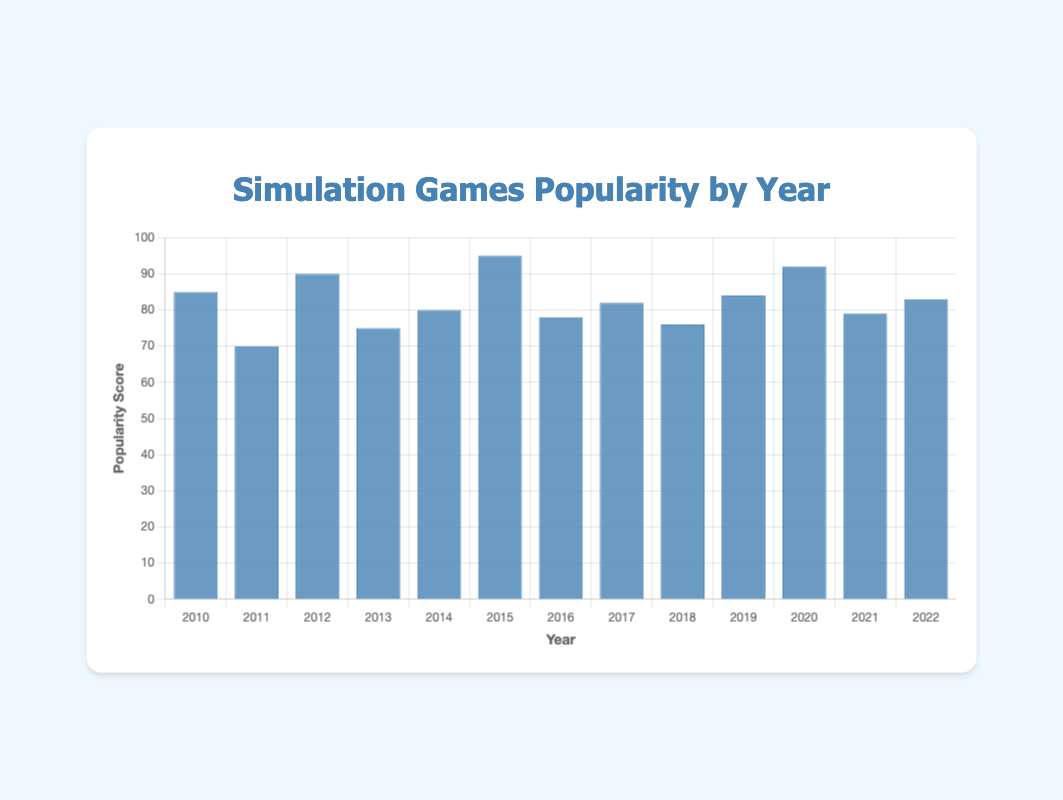Which year had the highest popularity score? Find the tallest blue bar in the chart. The bar for the year 2015 is the tallest, indicating the highest popularity score of 95.
Answer: 2015 Which game corresponded to the highest popularity score? Look at the highest bar representing the year 2015, then check the tooltip or data provided which shows that "Cities: Skylines" corresponded to the highest popularity score of 95.
Answer: Cities: Skylines What was the average popularity score over the years? Sum the popularity scores from 2010 to 2022 [85, 70, 90, 75, 80, 95, 78, 82, 76, 84, 92, 79, 83], resulting in 979. Then divide the sum by the number of years (13), which gives an average of 75.3.
Answer: 75.3 Which year had the lowest popularity score? Identify the shortest blue bar. The bar for the year 2011 is the shortest, indicating the lowest popularity score of 70.
Answer: 2011 What is the difference in popularity scores between the years 2014 and 2020? Subtract the popularity score of 2014 (80) from the popularity score of 2020 (92), resulting in a difference of 12.
Answer: 12 How many games had a popularity score above 80? Count the number of bars that extend above the 80 mark. The bars for the years 2010, 2012, 2014, 2015, 2017, 2019, 2020, and 2022 total to 8 games.
Answer: 8 During which year was the popularity score closest to 75? Compare the popularity scores around the score of 75: 2013 (75), 2016 (78), 2018 (76), and 2021 (79). The year 2013 is exactly at 75.
Answer: 2013 Is the popularity score of "The Sims 4" in 2014 higher or lower than that of "Microsoft Flight Simulator" in 2020? Compare the heights of the bars for 2014 and 2020. The score for 2014 (80) is lower than 2020 (92).
Answer: Lower Which game saw an increase in popularity relative to its predecessor from one year to the next? Look for consecutive bars where the latter bar is taller. "The Sims 4: Cottage Living" (79) in 2021 saw an increase from "Microsoft Flight Simulator" (92) in 2020.
Answer: "The Sims 4: Cottage Living" from 2020 to 2021 